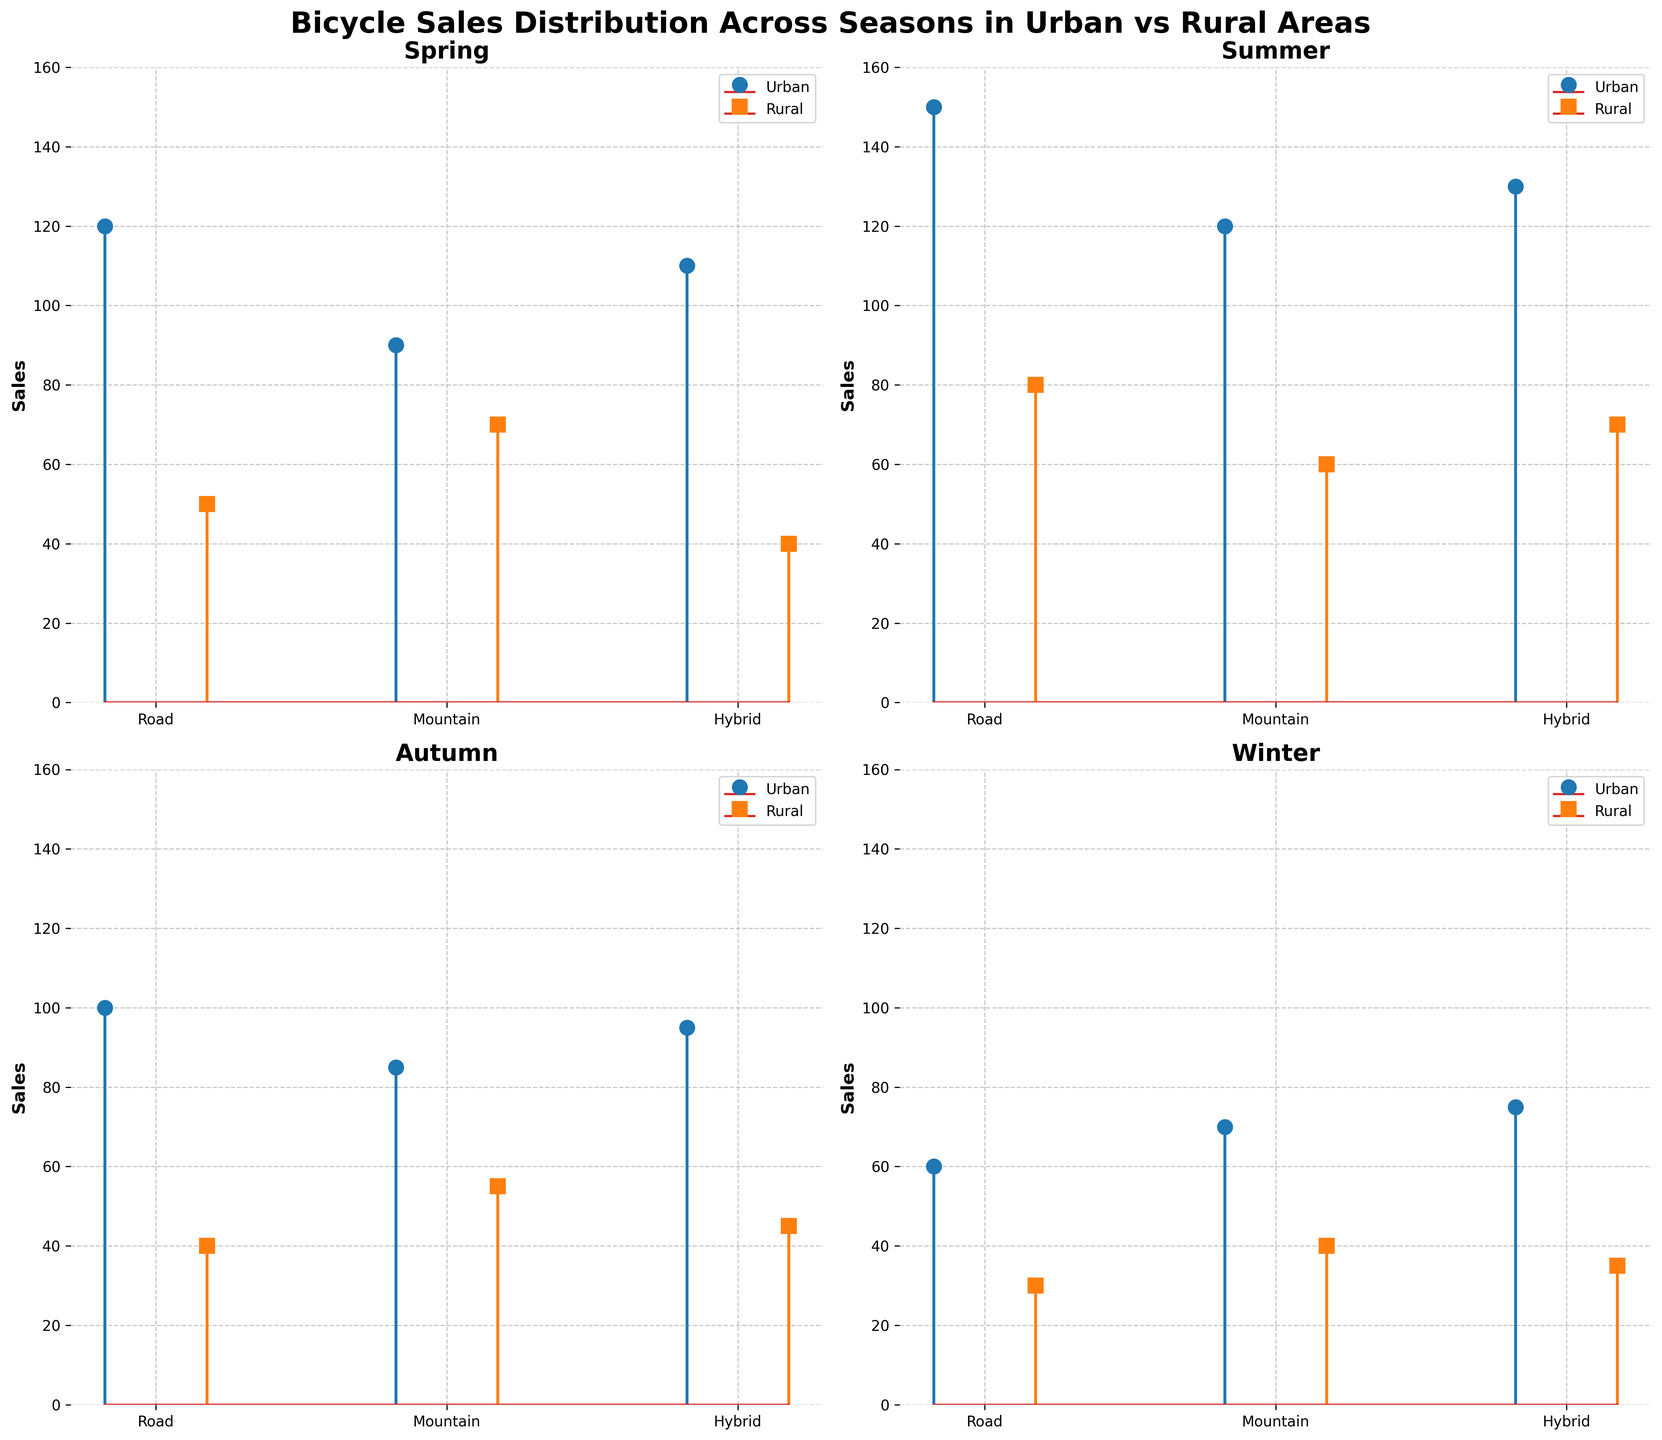What season has the highest total sales for Urban areas? By looking at the plots for each season, we add the sales of Road, Mountain, and Hybrid bikes for Urban areas: Spring (120 + 90 + 110), Summer (150 + 120 + 130), Autumn (100 + 85 + 95), Winter (60 + 70 + 75). Summer has the highest total with 400 sales.
Answer: Summer In which season are sales of Hybrid bicycles in Rural areas highest? Check the sales values for Hybrid bicycles in Rural areas for each season: Spring (40), Summer (70), Autumn (45), Winter (35). The highest is in Summer with 70 sales.
Answer: Summer Which area has higher Road bicycle sales in Autumn? Look at the sales in the Autumn subplot, and compare Urban sales (100) with Rural sales (40). Urban is higher.
Answer: Urban What is the total sales of Mountain bikes in Winter across both Urban and Rural areas? Sum the sales of Mountain bikes in Urban (70) and Rural (40) areas in Winter. The total is 70 + 40 = 110.
Answer: 110 What's the average sales of Hybrid bicycles in Urban areas across all seasons? Calculate the average by summing Hybrid bike sales in Urban areas for each season and dividing by the number of seasons: (110 + 130 + 95 + 75) / 4 = 410 / 4 = 102.5.
Answer: 102.5 Which season has the biggest difference in Road bicycle sales between Urban and Rural areas? Calculate the difference for Road bikes between Urban and Rural areas in each season: Spring (120 - 50 = 70), Summer (150 - 80 = 70), Autumn (100 - 40 = 60), Winter (60 - 30 = 30). The biggest difference is in Spring and Summer with a difference of 70.
Answer: Spring and Summer How do sales of Mountain bikes in Urban areas compare between Summer and Winter? Compare the sales of Mountain bikes in Urban areas between these two seasons, Summer (120) and Winter (70). Sales are higher in Summer.
Answer: Higher in Summer What is the total sales of all bicycle types in Rural areas in Spring? Add the sales of Road, Mountain, and Hybrid bikes in Rural areas in Spring: 50 + 70 + 40 = 160.
Answer: 160 In which season are Road bicycle sales the lowest in Urban areas? Check Road bike sales in Urban areas for each season: Spring (120), Summer (150), Autumn (100), Winter (60). The lowest is in Winter with 60 sales.
Answer: Winter 